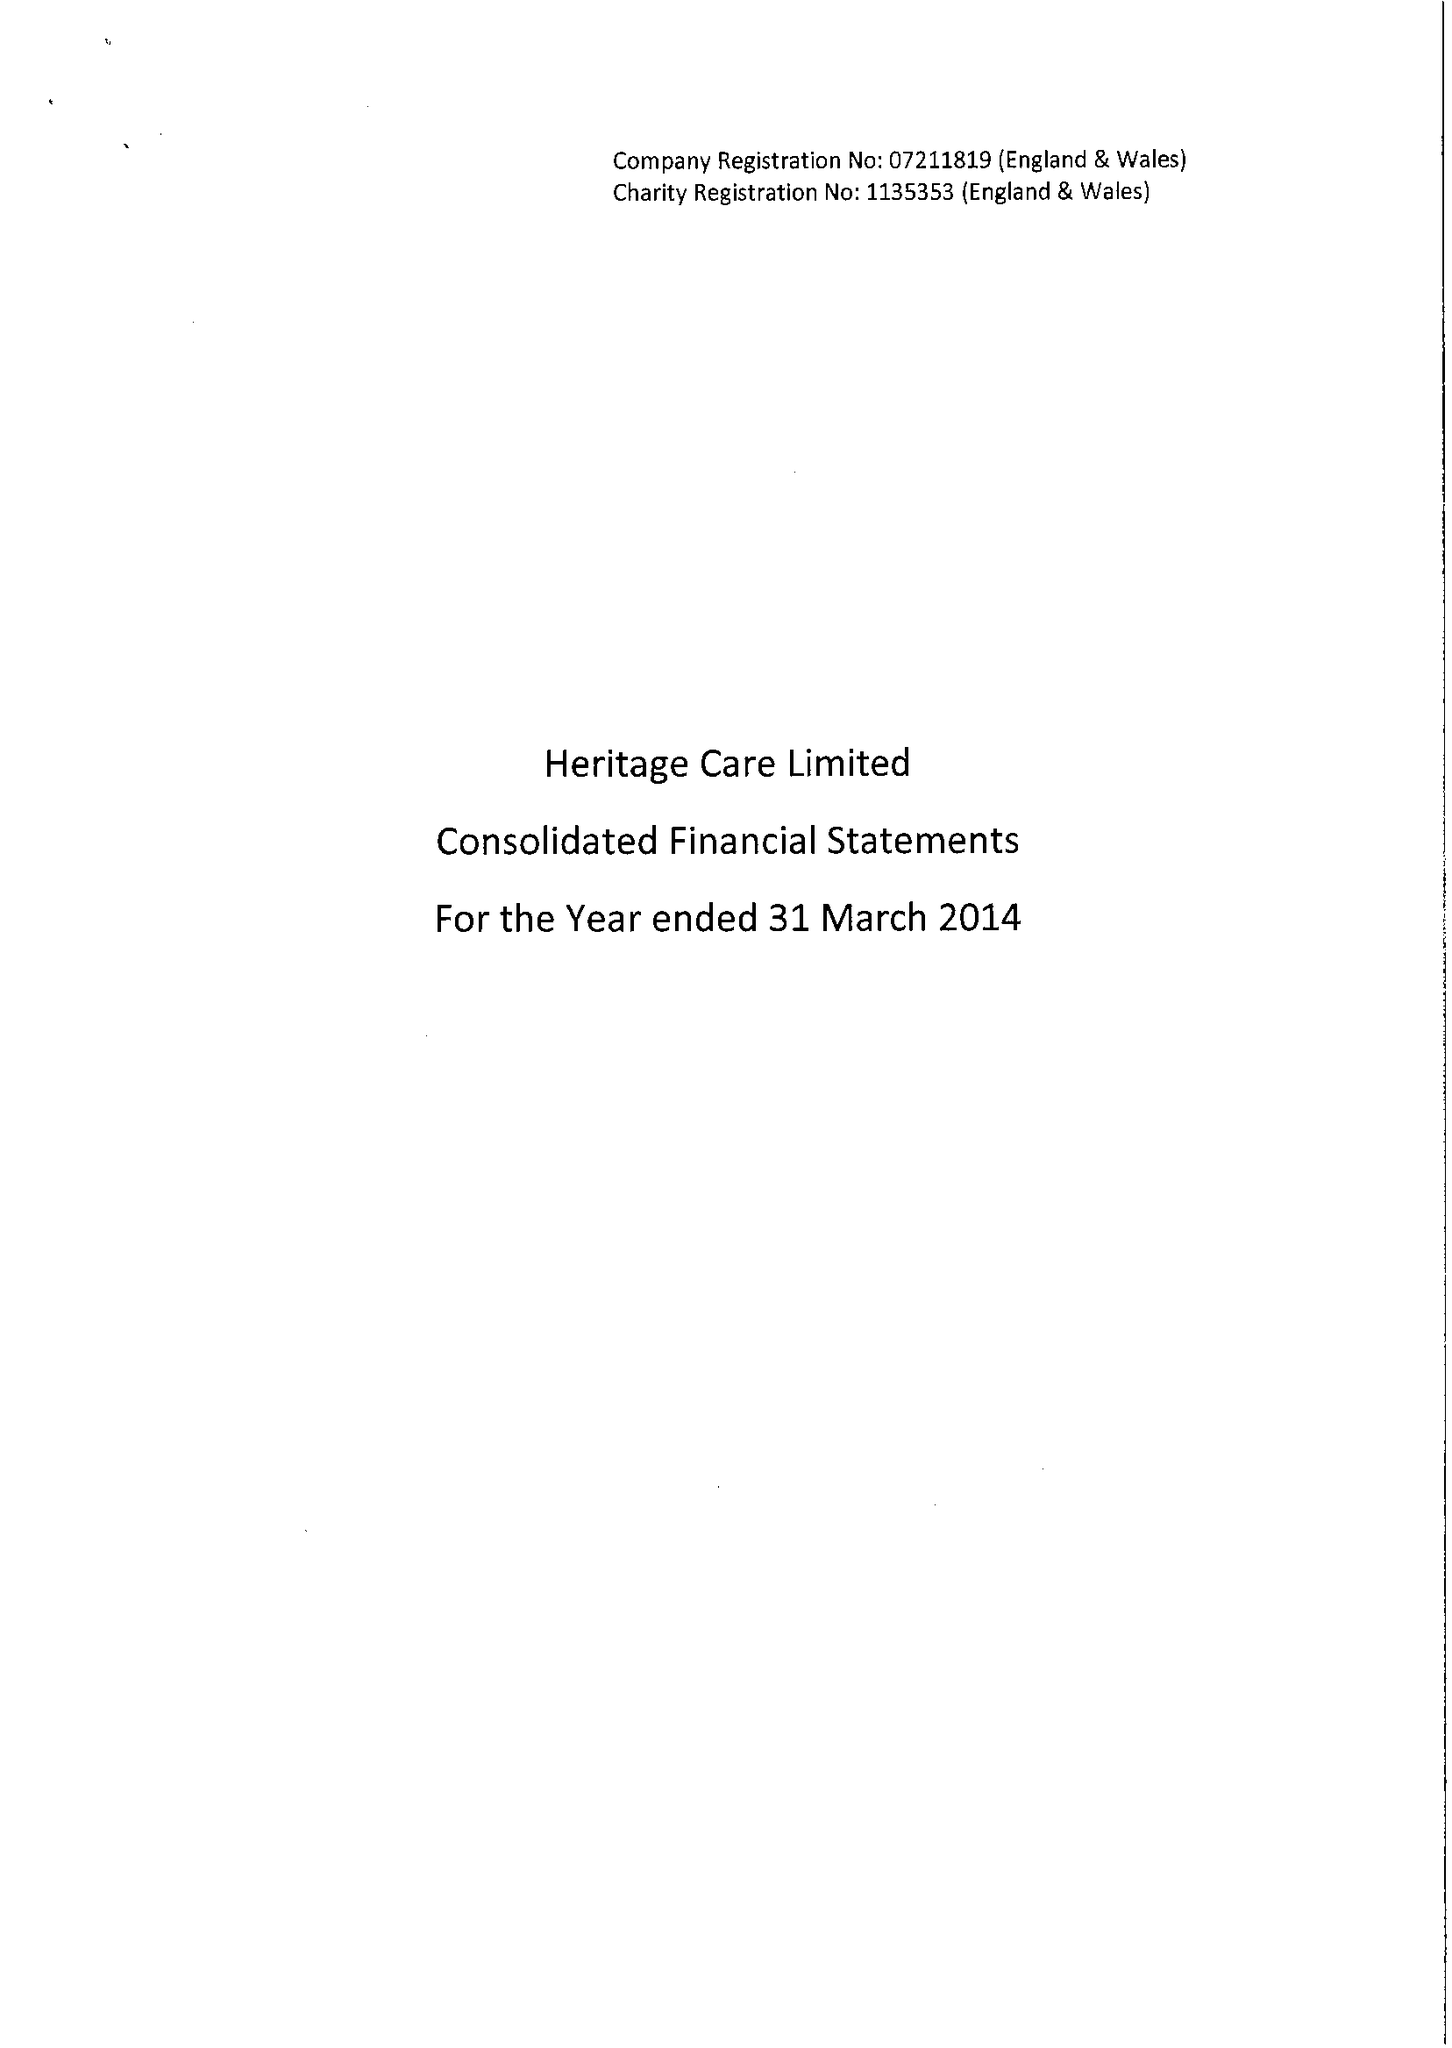What is the value for the address__post_town?
Answer the question using a single word or phrase. LOUGHTON 